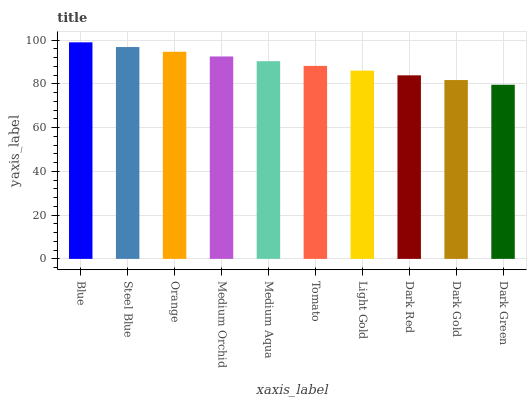Is Dark Green the minimum?
Answer yes or no. Yes. Is Blue the maximum?
Answer yes or no. Yes. Is Steel Blue the minimum?
Answer yes or no. No. Is Steel Blue the maximum?
Answer yes or no. No. Is Blue greater than Steel Blue?
Answer yes or no. Yes. Is Steel Blue less than Blue?
Answer yes or no. Yes. Is Steel Blue greater than Blue?
Answer yes or no. No. Is Blue less than Steel Blue?
Answer yes or no. No. Is Medium Aqua the high median?
Answer yes or no. Yes. Is Tomato the low median?
Answer yes or no. Yes. Is Dark Green the high median?
Answer yes or no. No. Is Blue the low median?
Answer yes or no. No. 